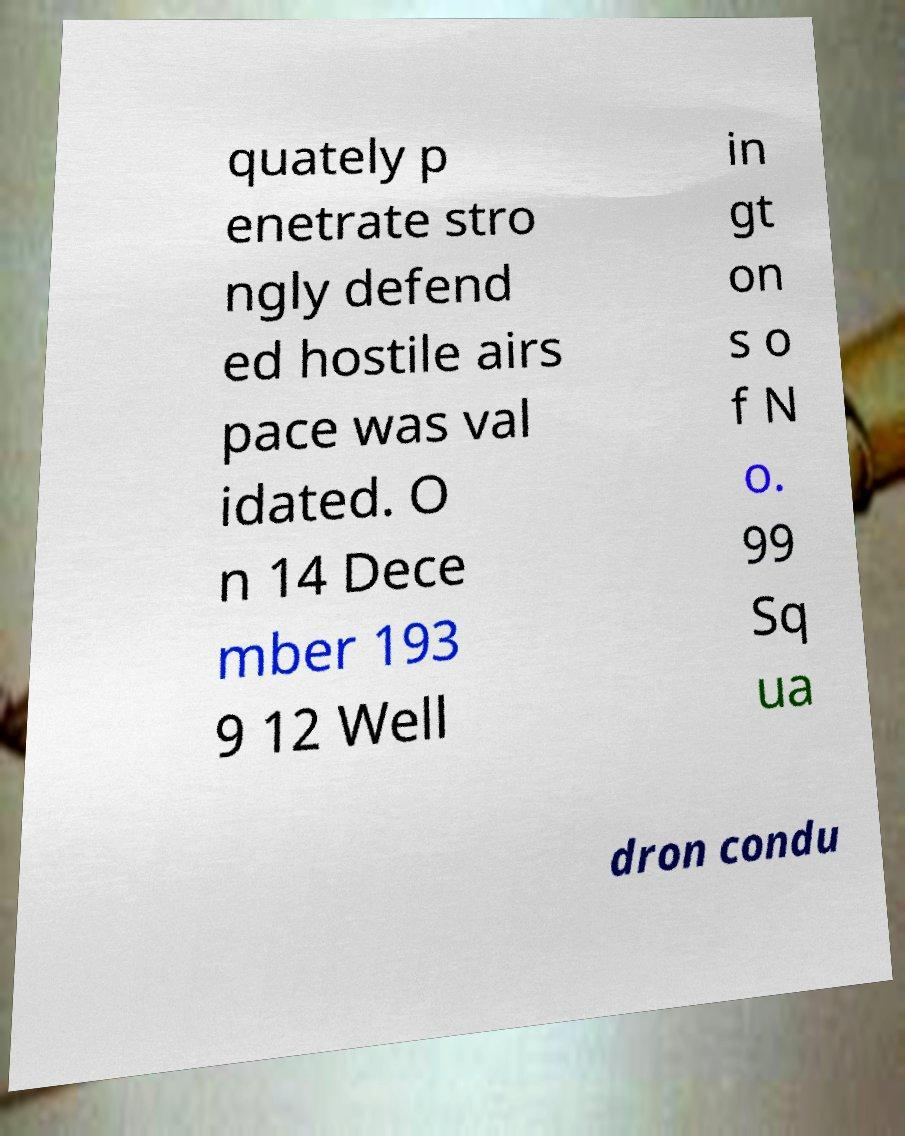Can you read and provide the text displayed in the image?This photo seems to have some interesting text. Can you extract and type it out for me? quately p enetrate stro ngly defend ed hostile airs pace was val idated. O n 14 Dece mber 193 9 12 Well in gt on s o f N o. 99 Sq ua dron condu 